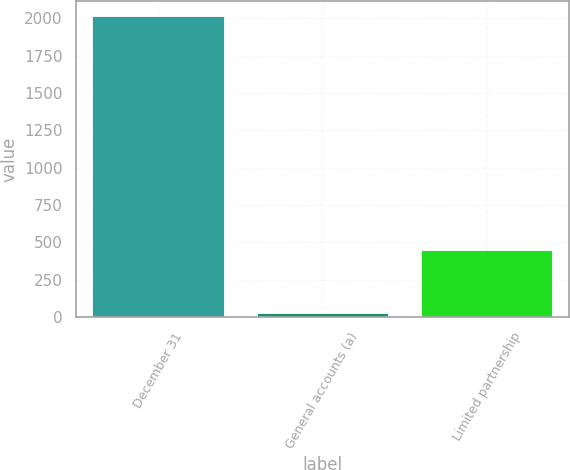Convert chart to OTSL. <chart><loc_0><loc_0><loc_500><loc_500><bar_chart><fcel>December 31<fcel>General accounts (a)<fcel>Limited partnership<nl><fcel>2016<fcel>28<fcel>449<nl></chart> 